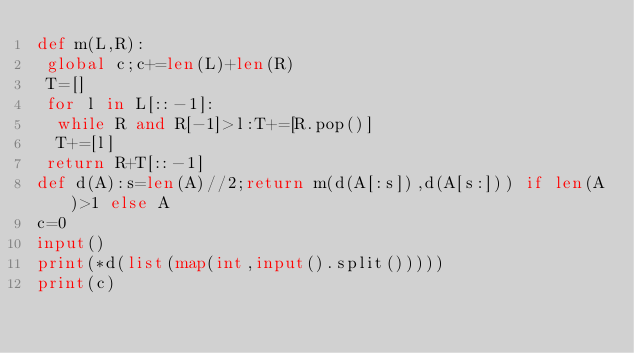<code> <loc_0><loc_0><loc_500><loc_500><_Python_>def m(L,R):
 global c;c+=len(L)+len(R)
 T=[]
 for l in L[::-1]:
  while R and R[-1]>l:T+=[R.pop()]
  T+=[l]
 return R+T[::-1]
def d(A):s=len(A)//2;return m(d(A[:s]),d(A[s:])) if len(A)>1 else A
c=0
input()
print(*d(list(map(int,input().split()))))
print(c)
</code> 